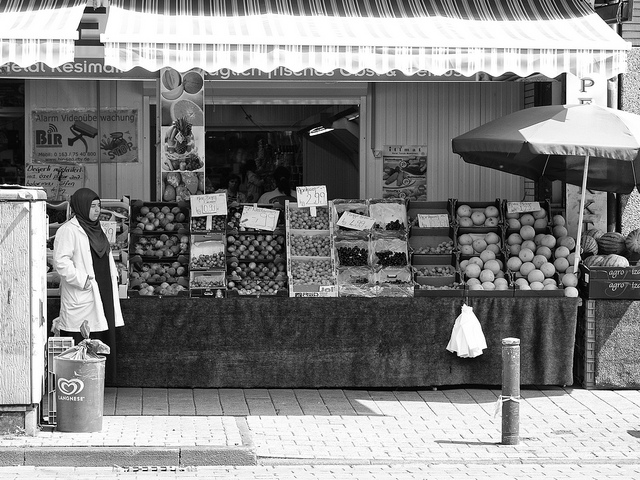Please transcribe the text in this image. BIR SP agro PKT 